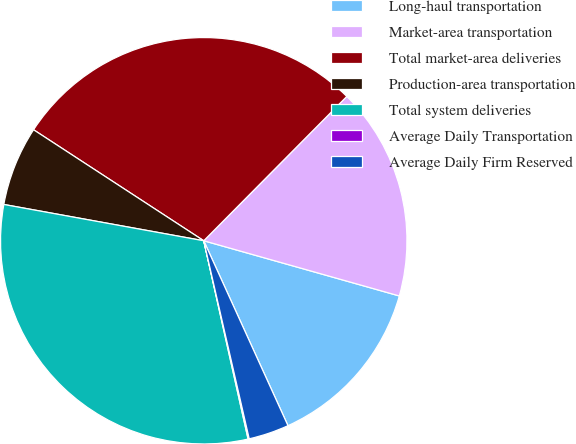Convert chart to OTSL. <chart><loc_0><loc_0><loc_500><loc_500><pie_chart><fcel>Long-haul transportation<fcel>Market-area transportation<fcel>Total market-area deliveries<fcel>Production-area transportation<fcel>Total system deliveries<fcel>Average Daily Transportation<fcel>Average Daily Firm Reserved<nl><fcel>13.82%<fcel>16.95%<fcel>28.23%<fcel>6.34%<fcel>31.36%<fcel>0.09%<fcel>3.21%<nl></chart> 